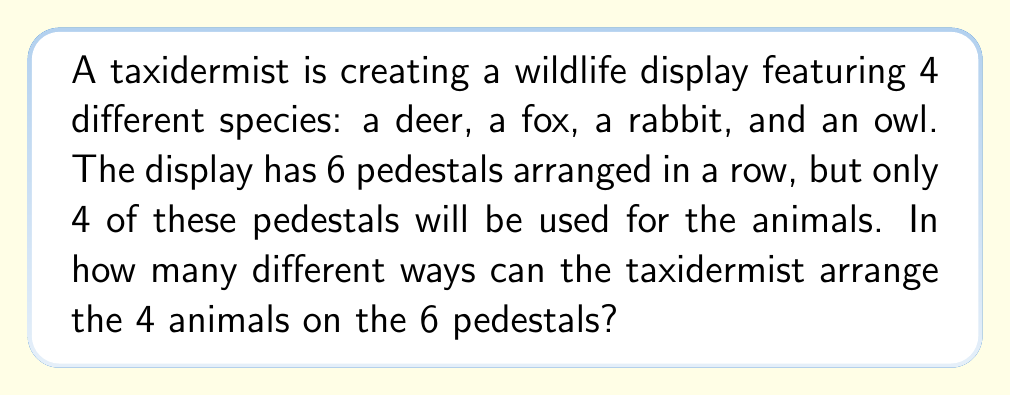Teach me how to tackle this problem. To solve this problem, we need to break it down into two steps:

1. Choose which 4 out of the 6 pedestals will be used.
2. Arrange the 4 animals on the chosen pedestals.

Step 1: Choosing 4 pedestals out of 6
This is a combination problem. We use the formula:

$${n \choose k} = \frac{n!}{k!(n-k)!}$$

Where $n = 6$ (total pedestals) and $k = 4$ (pedestals to be used).

$$\binom{6}{4} = \frac{6!}{4!(6-4)!} = \frac{6!}{4!2!} = 15$$

Step 2: Arranging 4 animals on 4 pedestals
This is a permutation of 4 distinct objects, which is simply $4!$.

$$4! = 4 \times 3 \times 2 \times 1 = 24$$

Final step: Multiply the results
By the multiplication principle, we multiply the number of ways to choose the pedestals by the number of ways to arrange the animals:

$$15 \times 24 = 360$$

Therefore, there are 360 different ways to arrange the 4 animals on the 6 pedestals.
Answer: 360 ways 